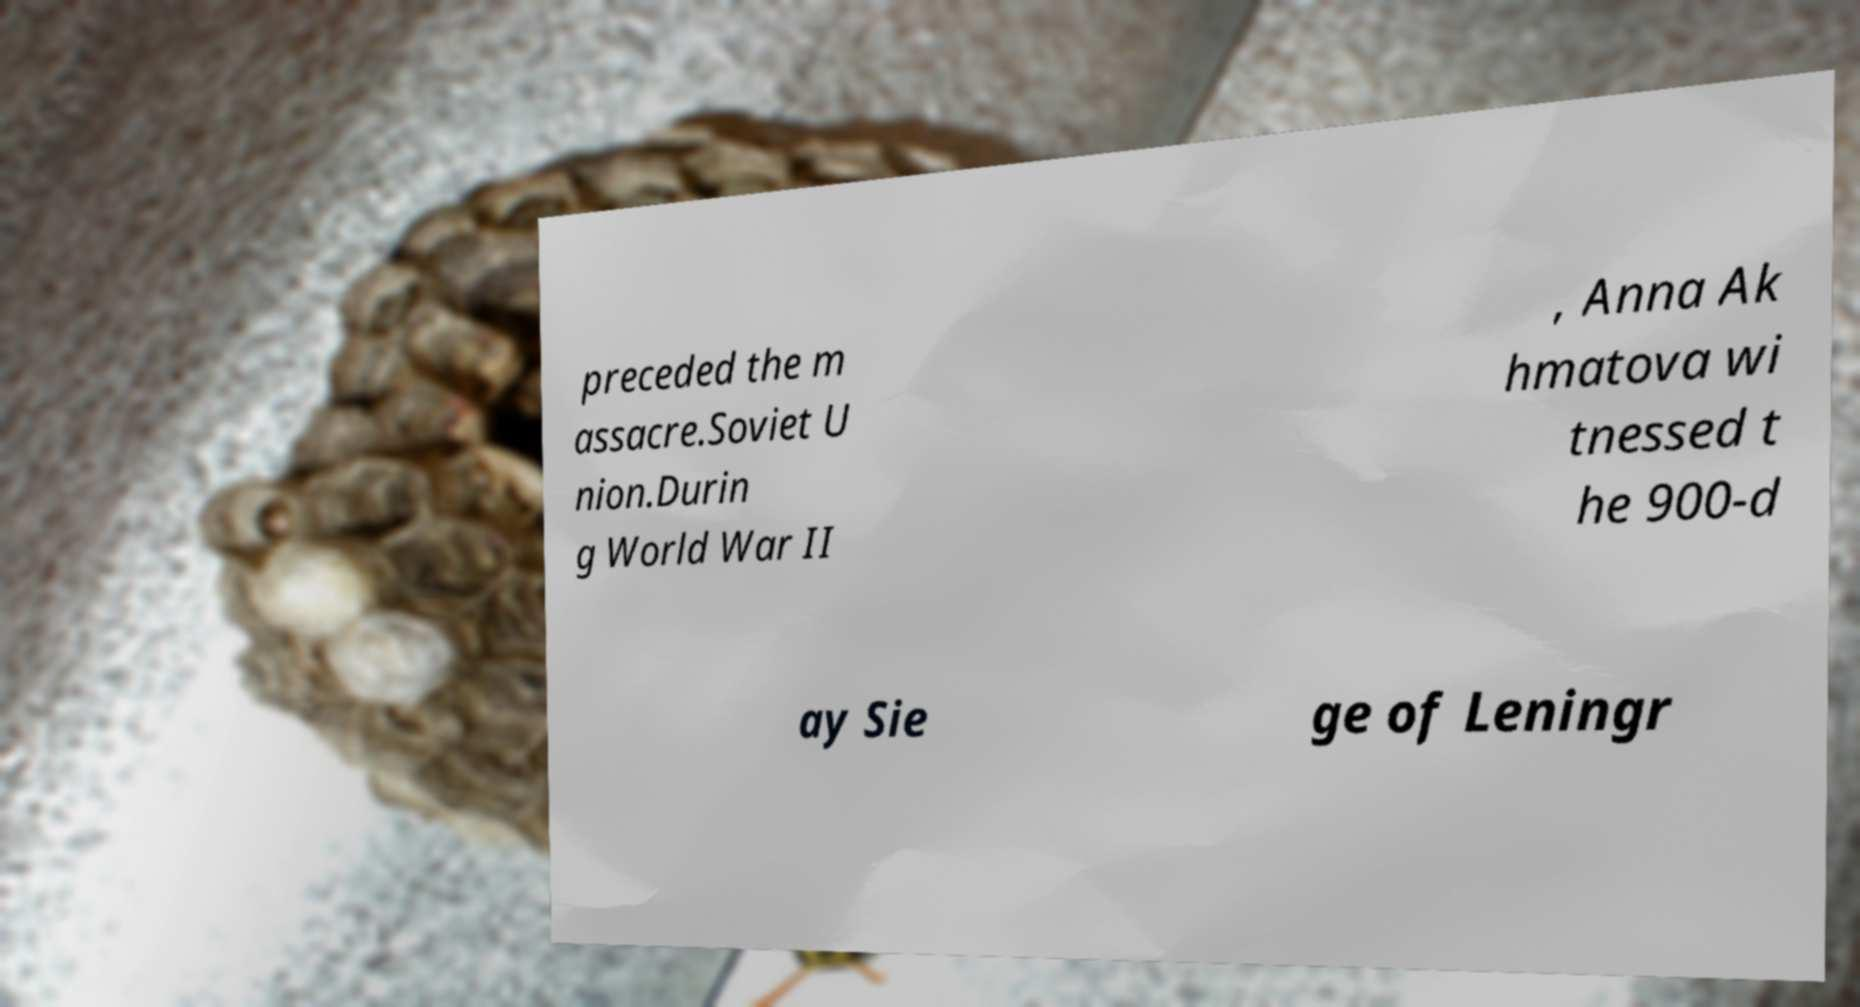Could you assist in decoding the text presented in this image and type it out clearly? preceded the m assacre.Soviet U nion.Durin g World War II , Anna Ak hmatova wi tnessed t he 900-d ay Sie ge of Leningr 